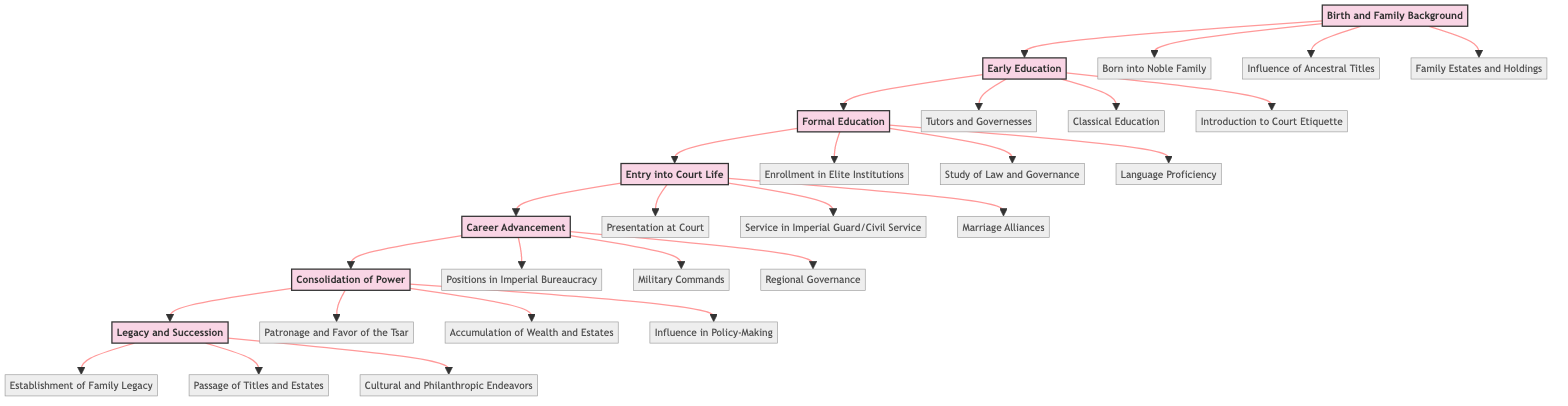What is the first stage in the lifecycle of Russian nobility? The first stage listed in the flow chart is "Birth and Family Background," indicating this is where the lifecycle begins.
Answer: Birth and Family Background How many stages are there in the lifecycle? The flow chart outlines seven distinct stages from Birth and Family Background to Legacy and Succession, making a total of seven stages.
Answer: 7 What comes after Formal Education? The diagram shows that after the "Formal Education" stage, the next stage is "Entry into Court Life."
Answer: Entry into Court Life What are the three details listed under Career Advancement? In the flow chart, the three details listed under "Career Advancement" are "Positions in Imperial Bureaucracy," "Military Commands," and "Regional Governance."
Answer: Positions in Imperial Bureaucracy, Military Commands, Regional Governance What type of education is indicated in the Early Education stage? The "Early Education" stage includes "Tutors and Governesses," "Classical Education," and "Introduction to Court Etiquette," indicating a focus on personalized and classical training.
Answer: Tutors and Governesses, Classical Education, Introduction to Court Etiquette What is required for the Consolidation of Power? The flow chart states that to consolidate power, one needs the "Patronage and Favor of the Tsar," along with "Accumulation of Wealth and Estates," and "Influence in Policy-Making."
Answer: Patronage and Favor of the Tsar, Accumulation of Wealth and Estates, Influence in Policy-Making What is the final stage indicating the outcome of the lifecycle? The last stage in the flow chart is "Legacy and Succession," which signifies the conclusion of the lifecycle for the Russian nobility.
Answer: Legacy and Succession How does one enter Court Life according to the chart? The flow chart indicates that one enters Court Life through "Presentation at Court," "Service in the Imperial Guard or Civil Service," and "Marriage Alliances with Other Noble Families," all of which serve as pathways into Court life.
Answer: Presentation at Court, Service in the Imperial Guard or Civil Service, Marriage Alliances with Other Noble Families Which educational focus is emphasized in the Formal Education stage? The "Formal Education" stage emphasizes enrolling in elite institutions, studying law and governance, and language proficiency, specifically in French and German, which equip nobles for their future roles.
Answer: Enrollment in Elite Institutions, Study of Law and Governance, Language Proficiency (French, German) 